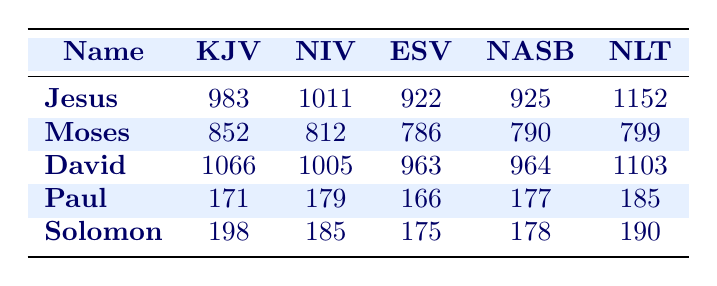What is the highest occurrence count for the name "Jesus"? The table shows the occurrences of "Jesus" in different translations. The highest occurrence is in the NLT, where it appears 1152 times.
Answer: 1152 Which translation has the least occurrences for the name "Moses"? Looking at the occurrences of "Moses," the ESV has the least with a count of 786.
Answer: 786 How many more times does the name "David" occur in the KJV than in the NASB? For "David," the KJV has 1066 occurrences, while the NASB has 964. The difference is calculated as 1066 - 964 = 102.
Answer: 102 Is it true that the NIV has more occurrences of "Paul" than the ESV? Checking the values, the NIV shows 179 occurrences and the ESV has 166 occurrences. Since 179 is greater than 166, the statement is true.
Answer: Yes What is the total count of occurrences for "Solomon" across all translations? To find the total for "Solomon," we sum the occurrences from each translation: 198 (KJV) + 185 (NIV) + 175 (ESV) + 178 (NASB) + 190 (NLT) = 926.
Answer: 926 Which name has the highest number of occurrences in the NLT? Looking specifically at the NLT column, the name "Jesus" has the highest occurrences at 1152, surpassing other names.
Answer: Jesus What is the average number of occurrences for the name "Paul" across all translations? To get the average, we add the occurrences of "Paul" from all translations: 171 + 179 + 166 + 177 + 185 = 878. Dividing by the number of translations (5), we get 878 / 5 = 175.6, which can be rounded to 176.
Answer: 176 Name the translation where "David" occurs the least. Referring to the occurrences listed, "David" appears least in the ESV with 963 counts compared to other translations.
Answer: ESV How many times does the name "Moses" occur in the KJV compared to the NIV? In the KJV, Moses appears 852 times, while in the NIV, it appears 812 times. The KJV count is higher, specifically, it has 40 more occurrences than NIV.
Answer: 40 What is the relationship between the occurrences of "Solomon" in the KJV and the occurrences of "Paul" in the NLT? "Solomon" occurs 198 times in the KJV, while "Paul" occurs 185 times in the NLT. The difference is 198 - 185 = 13, showing that "Solomon" occurs 13 times more in the KJV than "Paul" in the NLT.
Answer: 13 